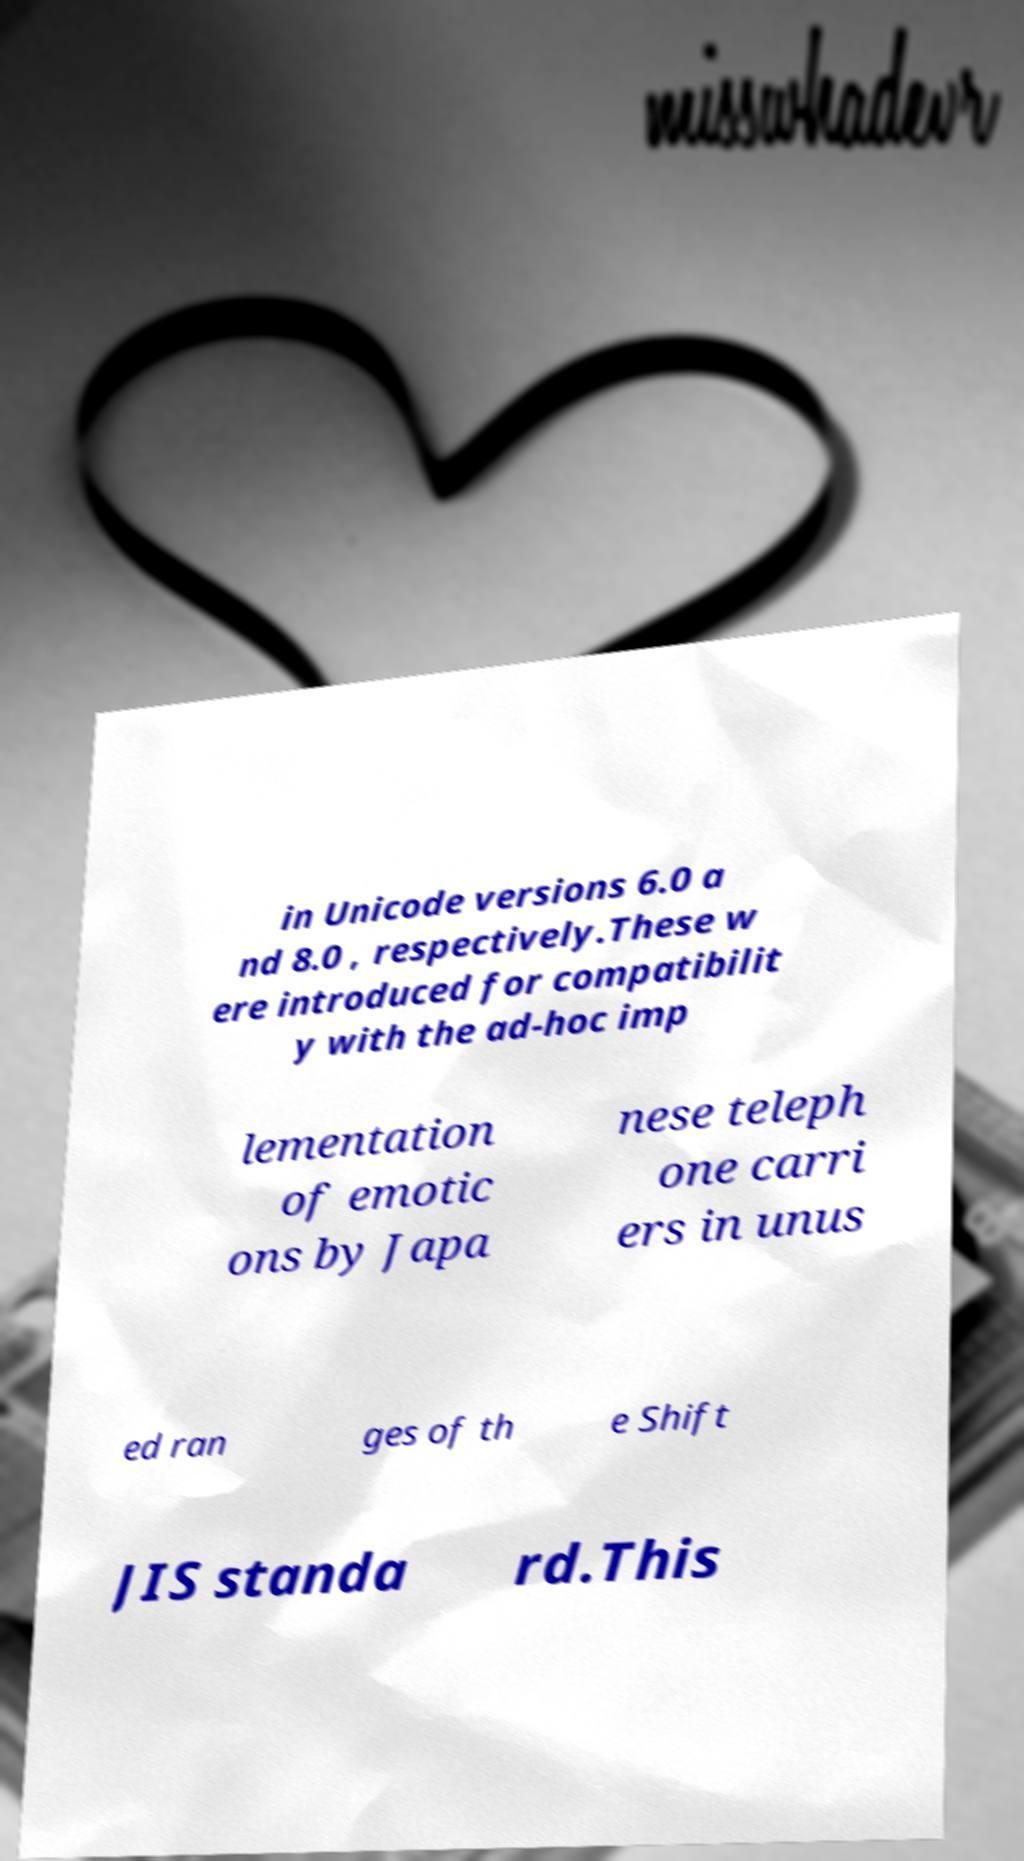Please read and relay the text visible in this image. What does it say? in Unicode versions 6.0 a nd 8.0 , respectively.These w ere introduced for compatibilit y with the ad-hoc imp lementation of emotic ons by Japa nese teleph one carri ers in unus ed ran ges of th e Shift JIS standa rd.This 